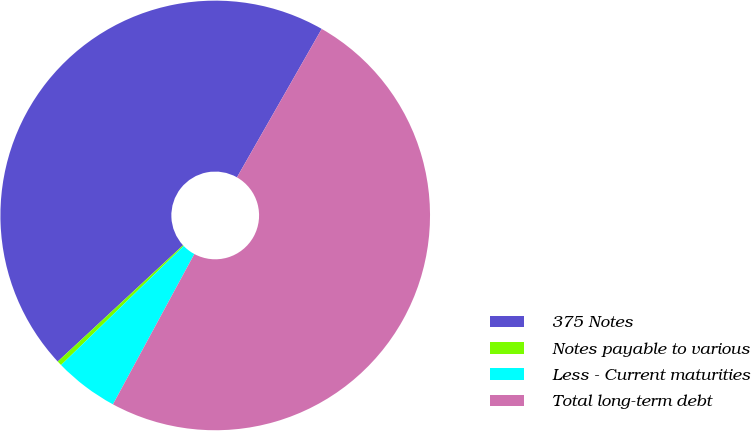Convert chart. <chart><loc_0><loc_0><loc_500><loc_500><pie_chart><fcel>375 Notes<fcel>Notes payable to various<fcel>Less - Current maturities<fcel>Total long-term debt<nl><fcel>45.16%<fcel>0.36%<fcel>4.84%<fcel>49.64%<nl></chart> 